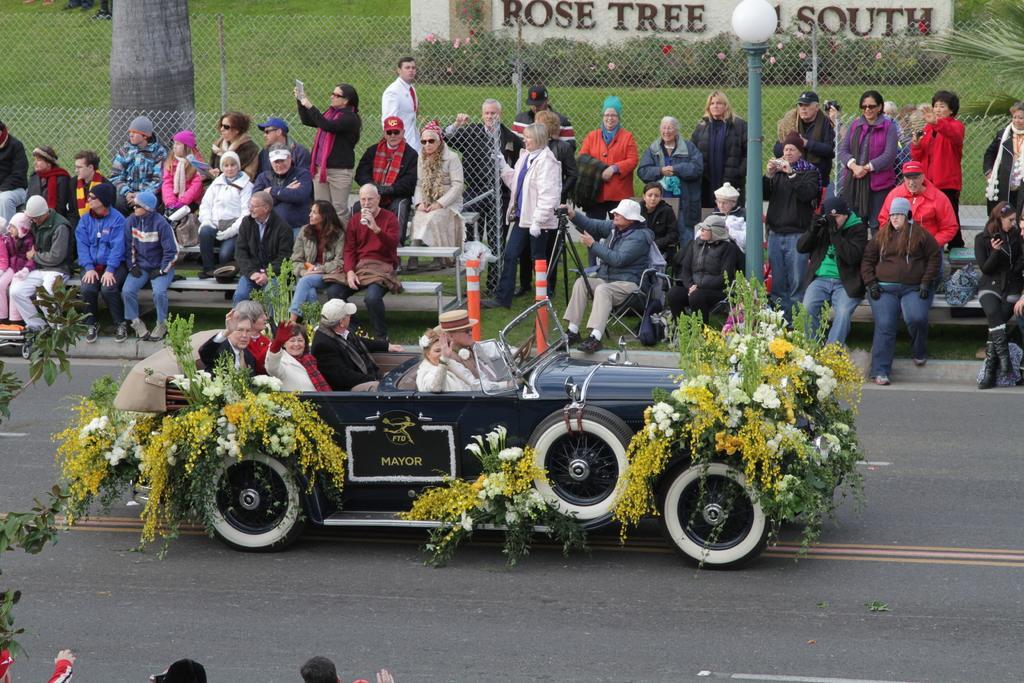Describe this image in one or two sentences. In this image I can see the road. I can see a vehicle decorated with the flowers. I can also see some text written on it. I can see some people. In the background, I can see the mesh and a tree. I can see a wall with some text written on it. 